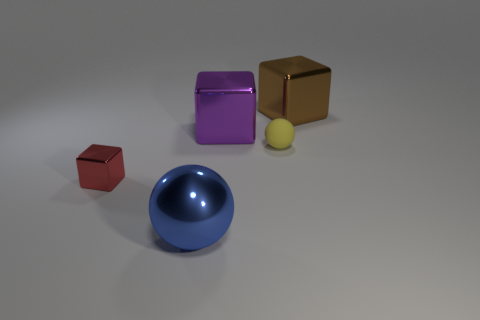What shape is the metallic object that is on the left side of the large metal ball? The metallic object to the left of the large metal ball is a cube. Its geometry is characterized by six equal square faces at 90-degree angles to each other, creating a perfectly symmetrical three-dimensional shape. The cube in the image has a reflective gold-colored surface, adding a visually appealing element to the composition of the objects present. 